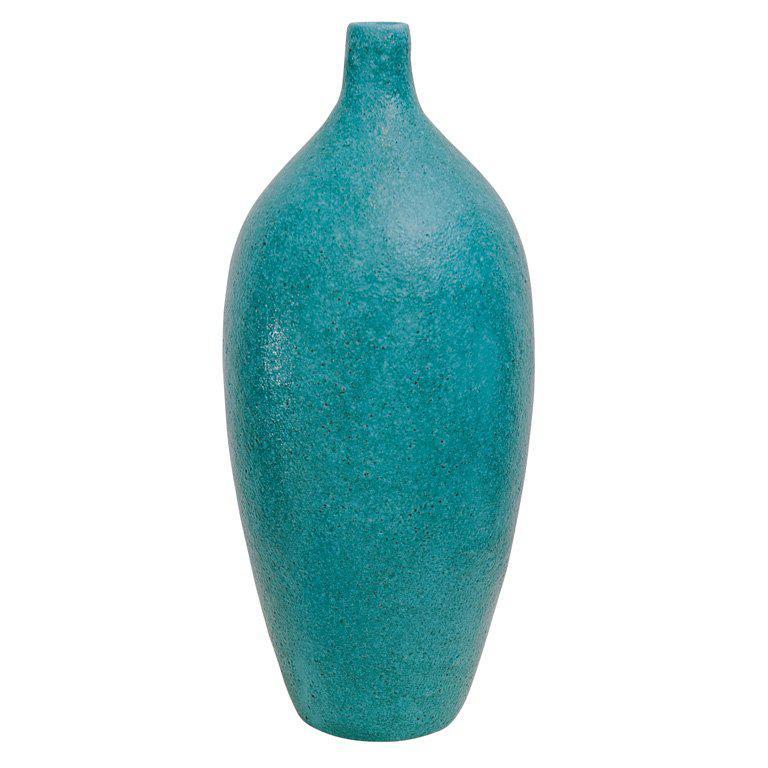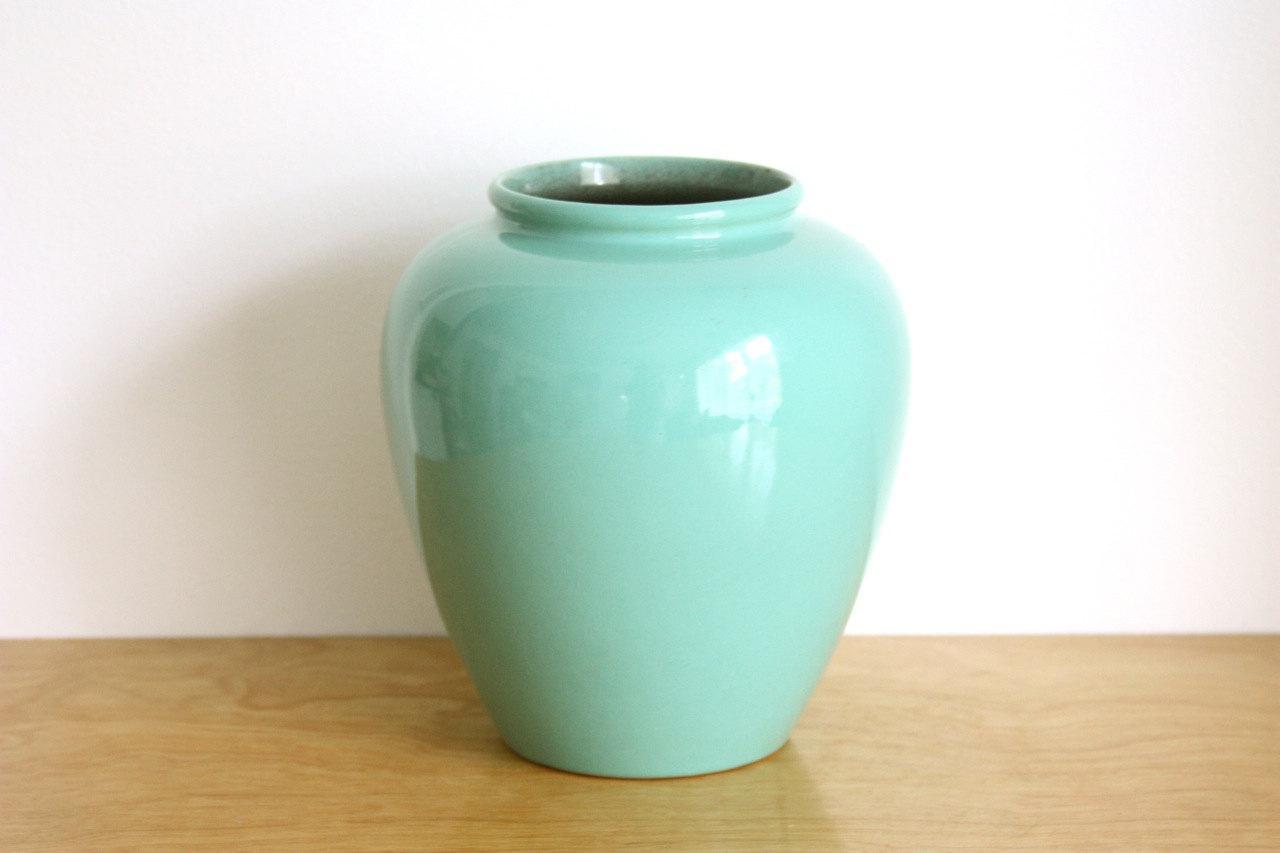The first image is the image on the left, the second image is the image on the right. For the images shown, is this caption "Four pieces of turquoise blue pottery are shown." true? Answer yes or no. No. The first image is the image on the left, the second image is the image on the right. Given the left and right images, does the statement "An image shows three turquoise blue vases." hold true? Answer yes or no. No. 